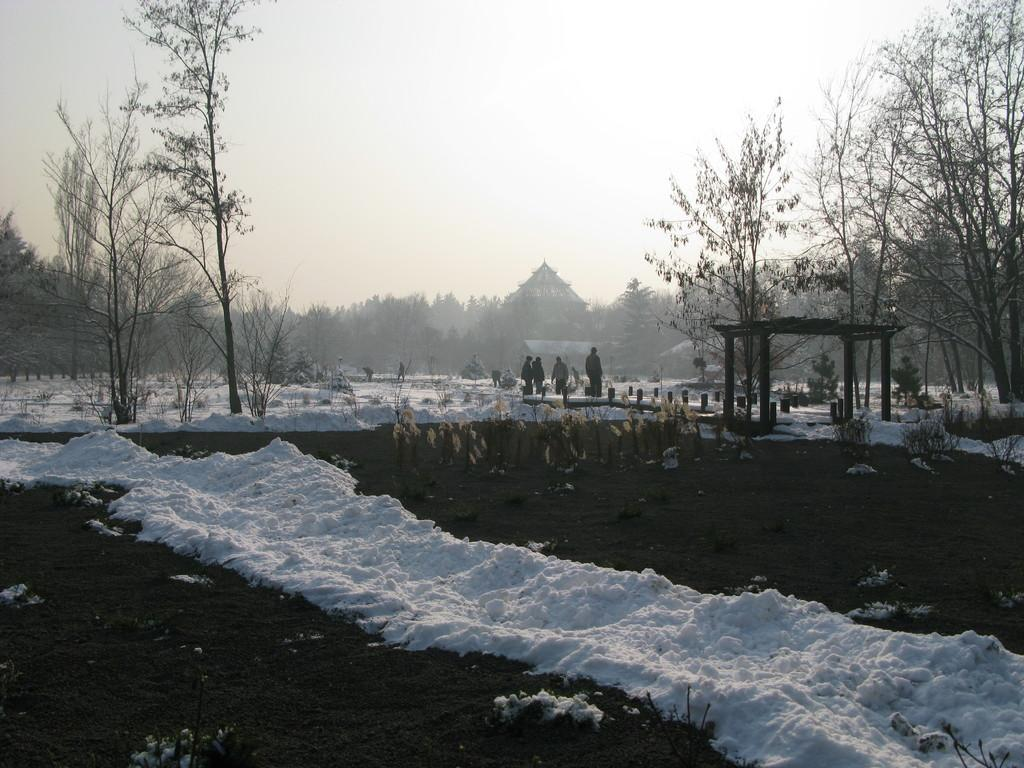What is the primary setting of the image? The primary setting of the image is outdoors, as there are people on the ground and snow visible. What type of vegetation can be seen in the image? There are trees in the image. What type of structure is present in the image? There is at least one building and a house in the image. What architectural feature can be seen in the image? There are pillars in the image. What is visible in the background of the image? The sky is visible in the background of the image. What type of flight is the partner taking in the image? There is no reference to a partner or flight in the image, so it is not possible to answer that question. 